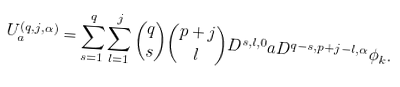<formula> <loc_0><loc_0><loc_500><loc_500>U _ { a } ^ { ( q , j , \alpha ) } = \sum ^ { q } _ { s = 1 } \sum ^ { j } _ { l = 1 } \binom { q } { s } \binom { p + j } { l } D ^ { s , l , 0 } a D ^ { q - s , p + j - l , \alpha } \phi _ { k } .</formula> 